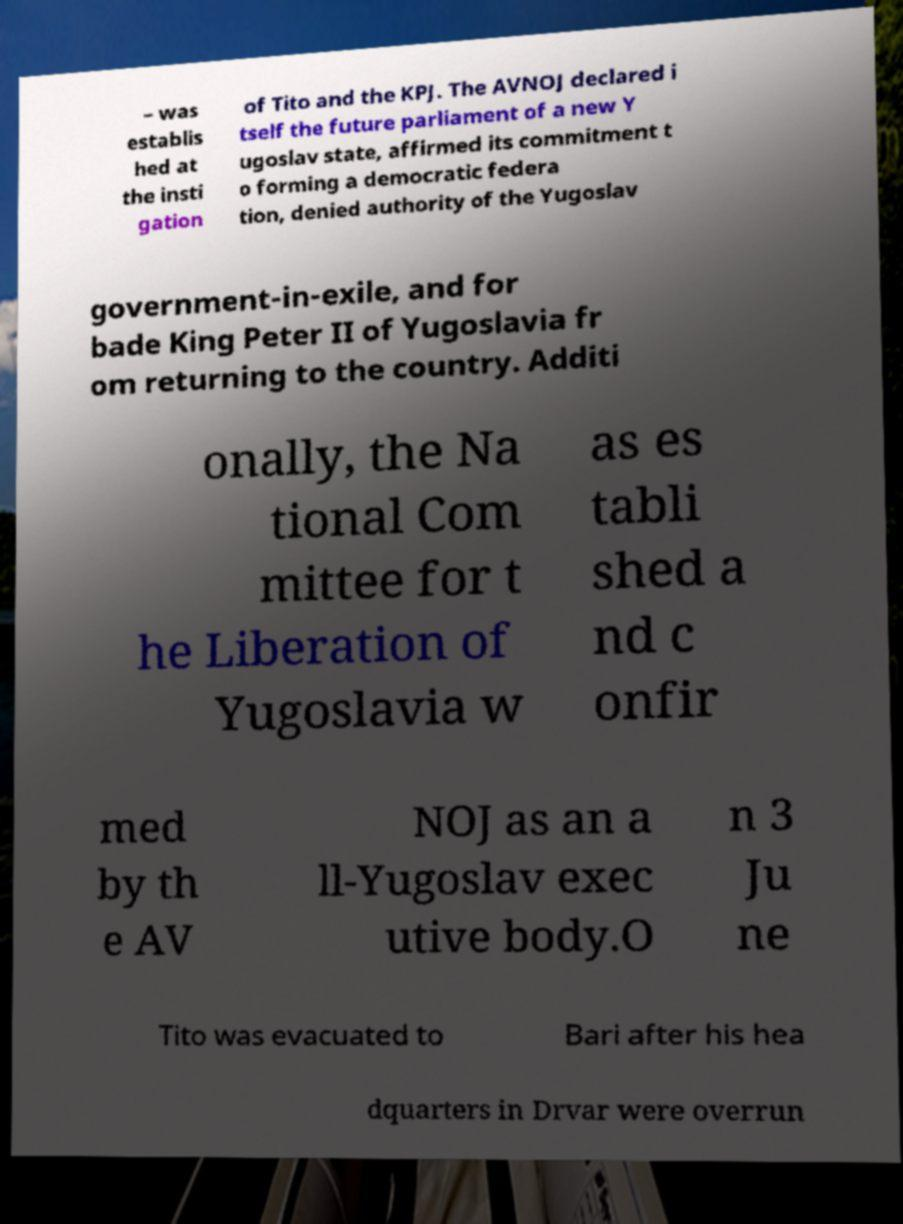There's text embedded in this image that I need extracted. Can you transcribe it verbatim? – was establis hed at the insti gation of Tito and the KPJ. The AVNOJ declared i tself the future parliament of a new Y ugoslav state, affirmed its commitment t o forming a democratic federa tion, denied authority of the Yugoslav government-in-exile, and for bade King Peter II of Yugoslavia fr om returning to the country. Additi onally, the Na tional Com mittee for t he Liberation of Yugoslavia w as es tabli shed a nd c onfir med by th e AV NOJ as an a ll-Yugoslav exec utive body.O n 3 Ju ne Tito was evacuated to Bari after his hea dquarters in Drvar were overrun 